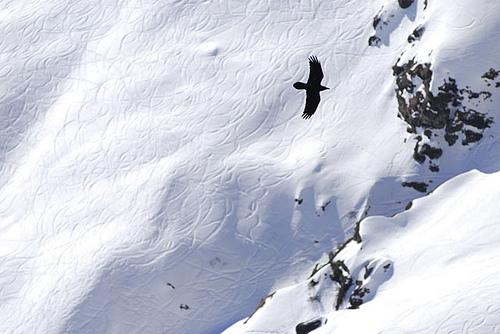What are three features found in the image, besides the bird? Exposed rock on a hill, sun shining on snow, a shadow on the white snow. Identify the sentiment or mood of the image. The image conveys a serene and peaceful mood, with a bird flying over a beautiful snow-covered landscape. In which direction is the bird flying in the image? The bird is flying over the snow-covered mountain, from left to right. Identify the main object in the image and provide two details about it. The main object is a black bird in flight, with feathers on its wing tip and a beak visible. Analyze the interaction between the bird and the background. The bird is flying above the snow-covered mountain, casting a contrasting silhouette against the white snow. Give a brief overview of the scene depicted in the image. A black bird is flying over a snow-covered mountain with exposed rock patches and a curved lines pattern in the snow. How many total objects have been detected in the image? Nine objects have been detected, including the bird, rock patches, shadows, curved lines, exposed rocks, wings, tails, beak, and head. Enumerate the visible body parts of the bird. Feathers on wing tip, tail, beak, head, and back. What is the dominant color in the image and what is the reason for it? The dominant color is white, due to the vast snow-covered landscape. What type of landscape is depicted in the image? A snow-covered mountain landscape with exposed rock patches. What is the bird doing in the image? flying over snow What is the overall tone or mood of the photo? peaceful, serene winter scene What is the main focal point of the image? the black bird in flight over snow What is the dominant color of the landscape? white Is the bird's position in the photo closer to the top-left corner or the bottom-right corner of the image? top-left corner Which object is at the coordinates X:298 Y:50? wing of a bird What is the likely altitude of the bird in relation to the ground? low altitude, flying close to the ground How many different captions describe a bird feature? 11 What emotions does the image evoke given its subject matter and color palette? tranquility, serenity, calmness What objects are exposed through the snow on the ground? rocks, rock patches, dry spot of mountain Detect any unusual elements in the image. There are curved lines in the snow that look like tracks. What type of scene is portrayed in the image? winter scene Are there any text or numbers visible in the image? No Identify the primary subjects in the image. bird in flight, snow, rocks, mountain Describe the interaction between the bird and its environment. The bird is flying over a snow-covered landscape with exposed rocks on the mountain. Rate the image clarity on a scale of 1 to 5, with 5 being the clearest. 4 Describe the patterns and textures visible in the snow. swirl pattern, tracks, sun shining on snow What is the sentiment of the image given the landscape setting and time of day? calm, peaceful Which objects are located in the top-right corner of the image? rock patches in snow, exposed rock in crevice List the attributes of the bird in the photo. black, flying, wings, beak, tail 